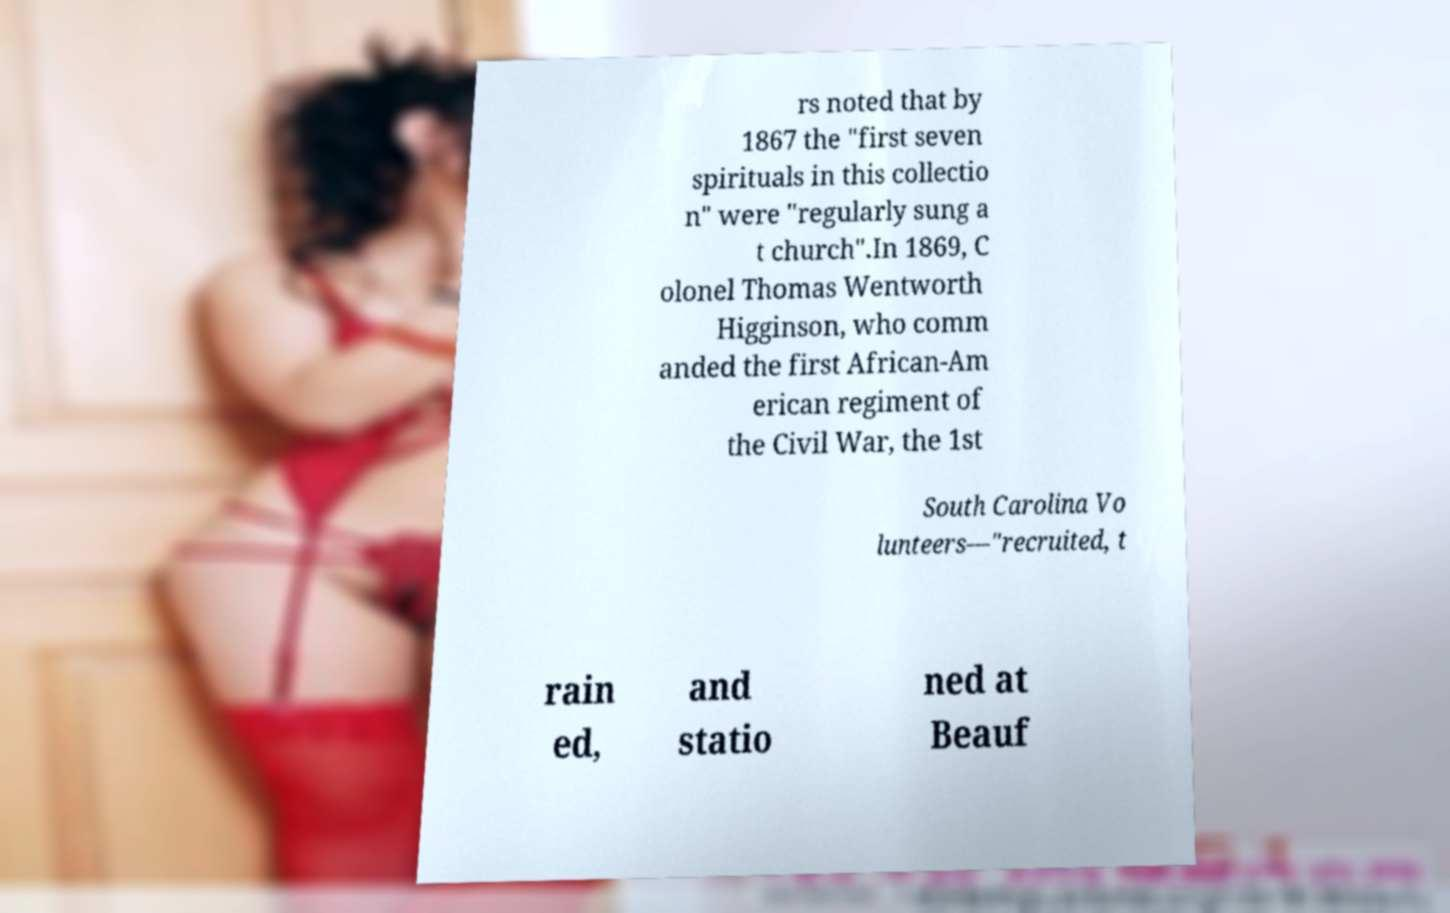What messages or text are displayed in this image? I need them in a readable, typed format. rs noted that by 1867 the "first seven spirituals in this collectio n" were "regularly sung a t church".In 1869, C olonel Thomas Wentworth Higginson, who comm anded the first African-Am erican regiment of the Civil War, the 1st South Carolina Vo lunteers—"recruited, t rain ed, and statio ned at Beauf 